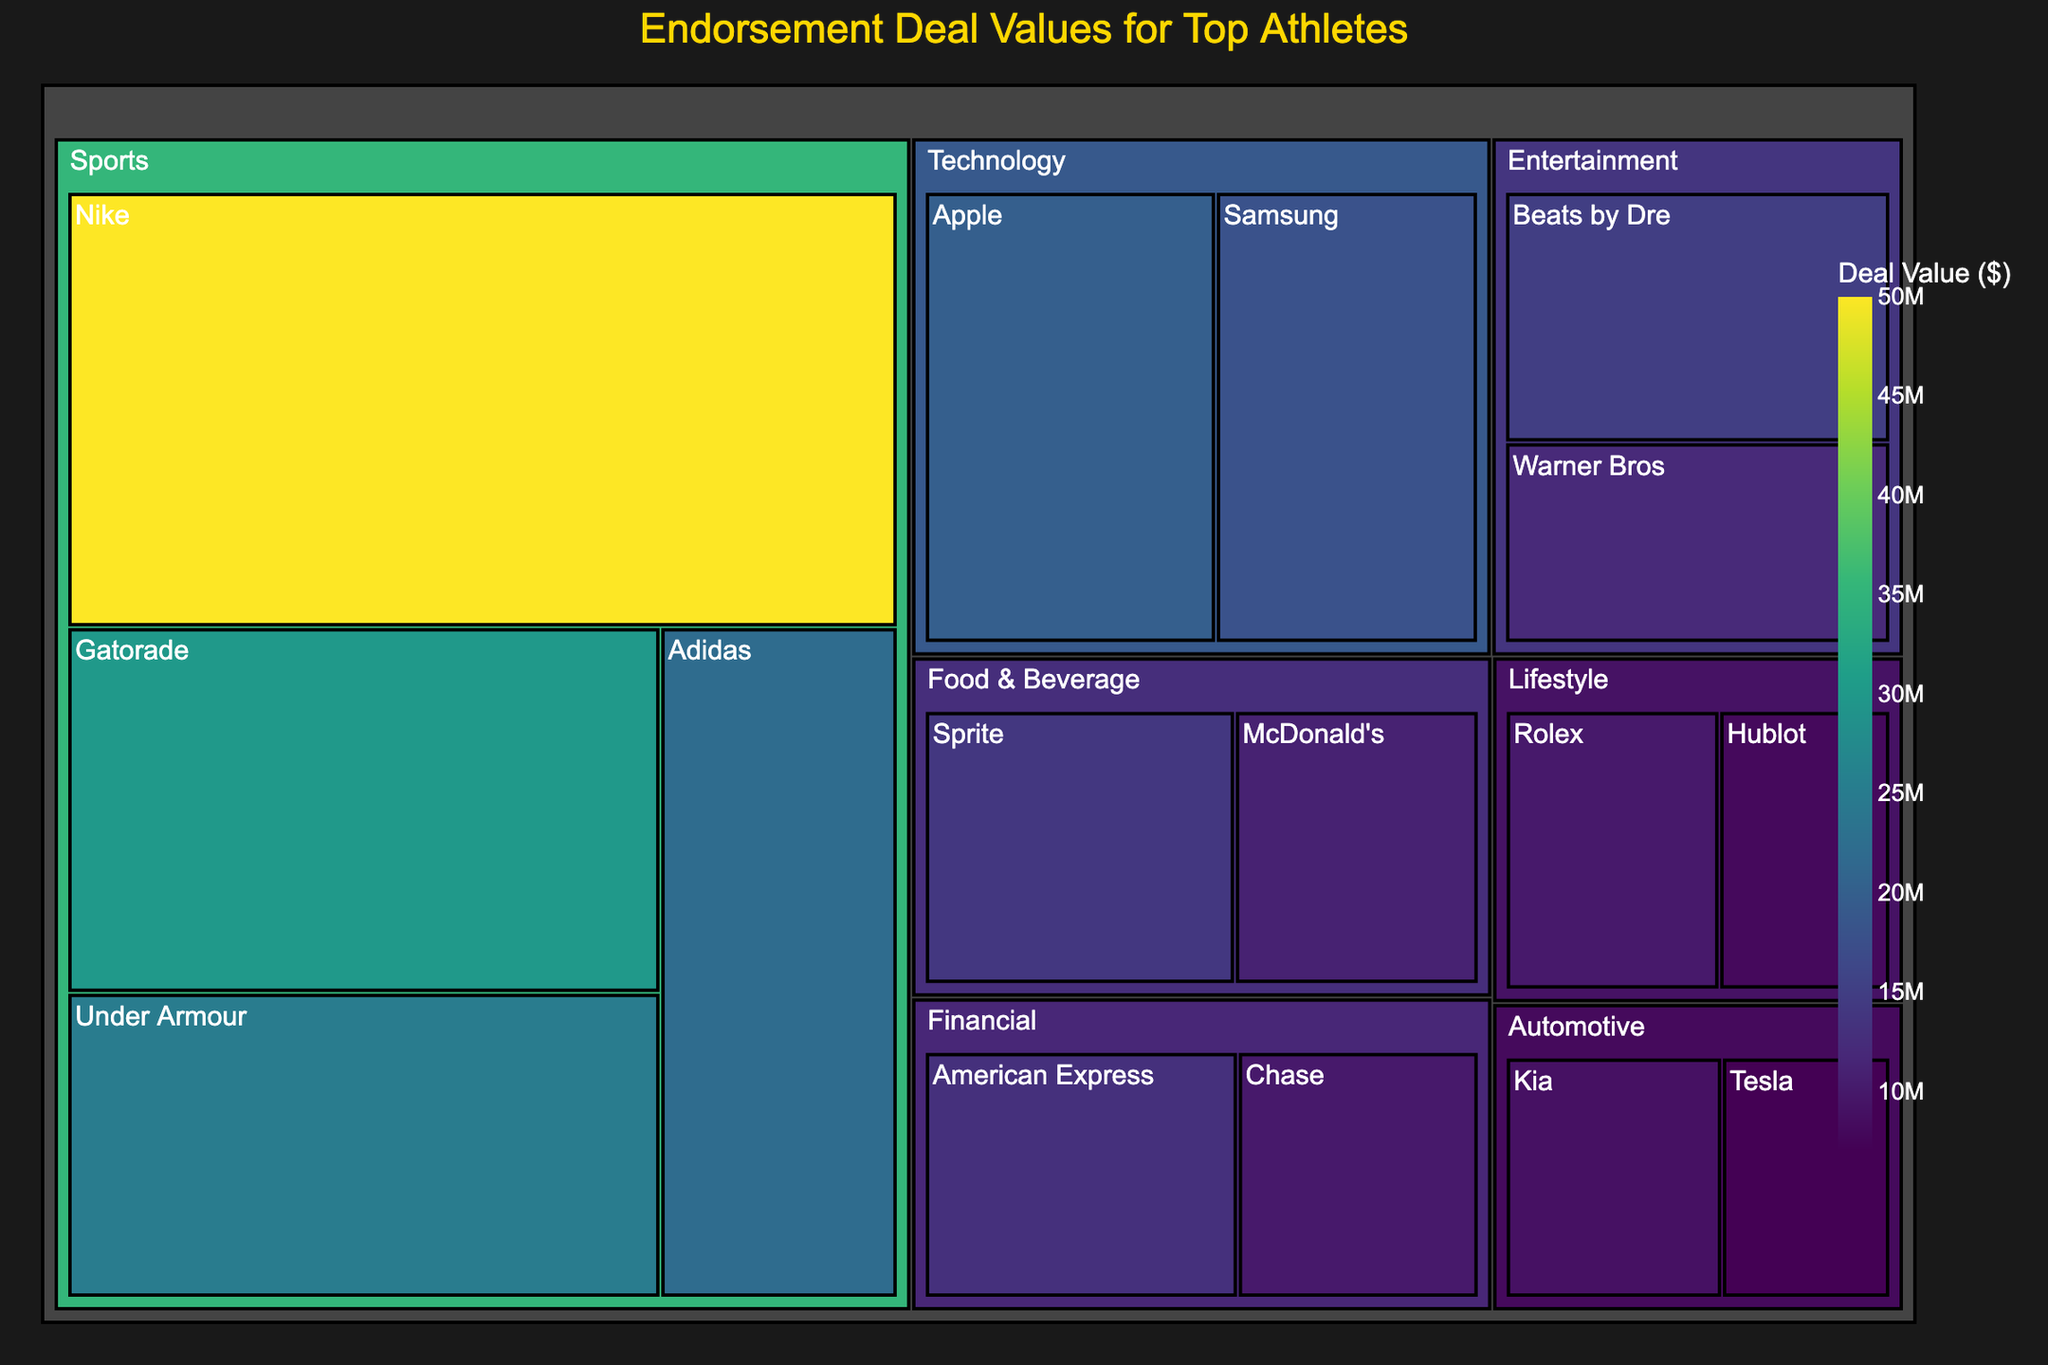What is the title of the Treemap? The title of the Treemap is displayed prominently at the top of the figure, usually in a larger font size and different color for emphasis.
Answer: Endorsement Deal Values for Top Athletes Which endorsement deal has the highest value? By looking at the size and color intensity of the boxes in the Treemap, the largest and darkest box indicates the highest value.
Answer: Nike ($50,000,000) What is the total endorsement value for the "Food & Beverage" category? To find the total endorsement value for the "Food & Beverage" category, sum the values of the subcategories within it (Sprite and McDonald's).
Answer: $25,000,000 Which subcategory in the "Technology" category has a higher endorsement value, Apple or Samsung? Compare the values displayed on the boxes for Apple and Samsung in the "Technology" category.
Answer: Apple ($20,000,000) How much more is the endorsement value of Nike compared to Hublot? Subtract the endorsement value of Hublot from the endorsement value of Nike to find the difference.
Answer: $42,000,000 What is the smallest endorsement value shown in the Treemap? Identify the subcategory with the smallest box size and color intensity, indicating the lowest value.
Answer: Tesla ($7,000,000) In which category does "Beats by Dre" belong, and what is its endorsement value? Locate "Beats by Dre" in the Treemap by reading the labels and colors, and identify its category and the value displayed.
Answer: Entertainment, $15,000,000 What are the total endorsement values for all subcategories within the "Sports" category? Sum the values of all subcategories (Nike, Gatorade, Under Armour, Adidas) within the "Sports" category.
Answer: $127,000,000 Which has a higher endorsement value, the "Entertainment" category or the "Automotive" category? Compare the sum of values for subcategories within each category. First, calculate each sum: Entertainment (Beats by Dre and Warner Bros) and Automotive (Kia and Tesla), then compare.
Answer: Entertainment ($27,000,000) 